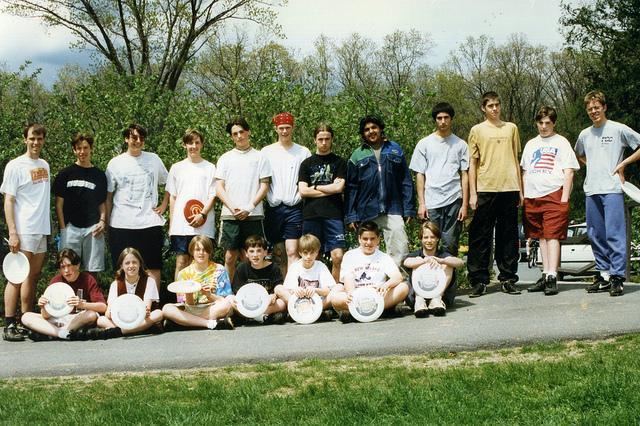How many kids are in the first row?
Give a very brief answer. 7. How many people are sitting down?
Give a very brief answer. 7. How many people can be seen?
Give a very brief answer. 14. 